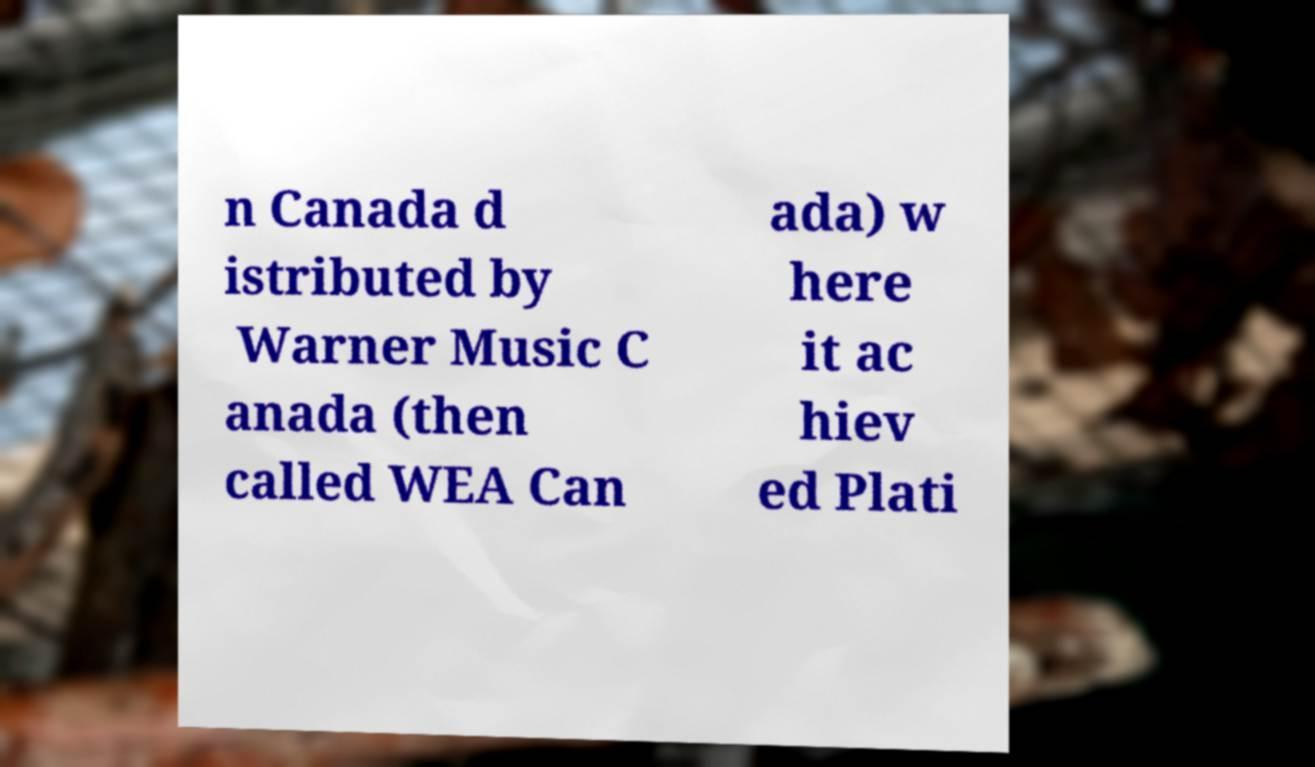Please identify and transcribe the text found in this image. n Canada d istributed by Warner Music C anada (then called WEA Can ada) w here it ac hiev ed Plati 